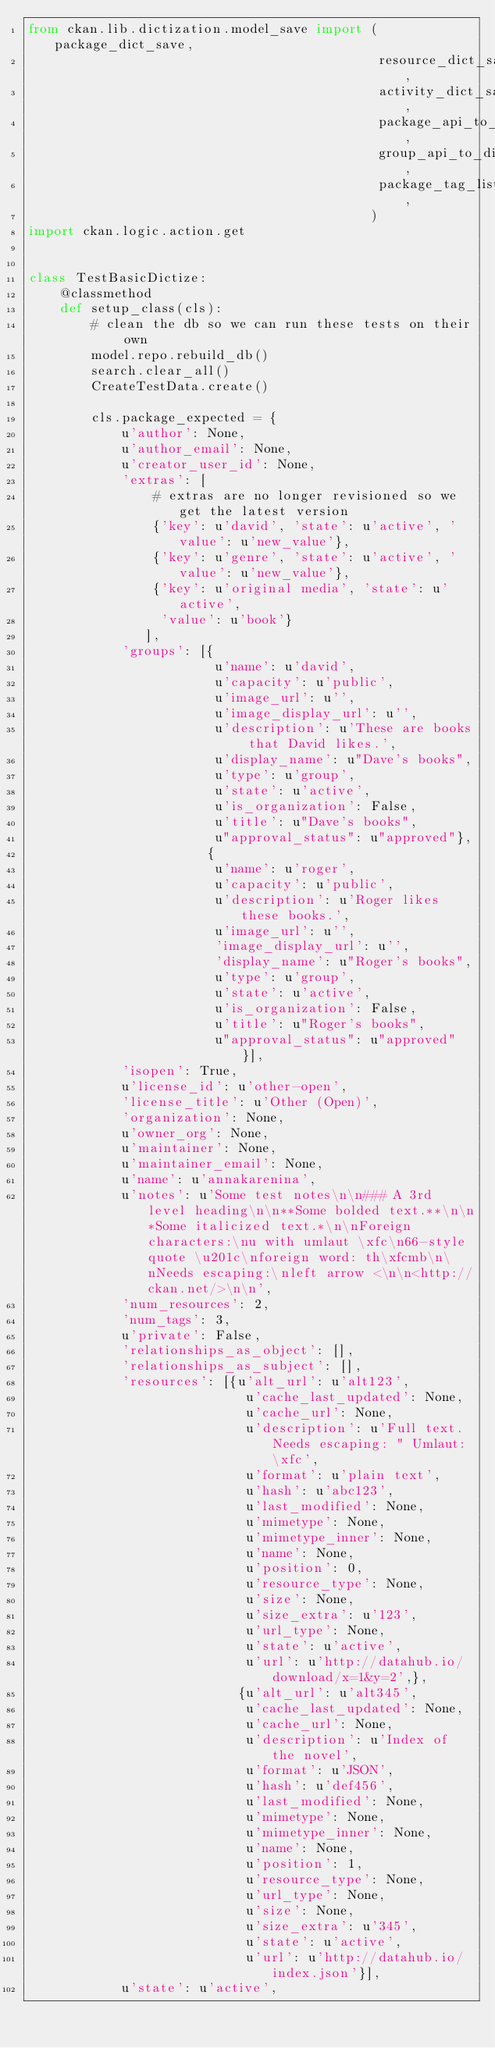<code> <loc_0><loc_0><loc_500><loc_500><_Python_>from ckan.lib.dictization.model_save import (package_dict_save,
                                             resource_dict_save,
                                             activity_dict_save,
                                             package_api_to_dict,
                                             group_api_to_dict,
                                             package_tag_list_save,
                                            )
import ckan.logic.action.get


class TestBasicDictize:
    @classmethod
    def setup_class(cls):
        # clean the db so we can run these tests on their own
        model.repo.rebuild_db()
        search.clear_all()
        CreateTestData.create()

        cls.package_expected = {
            u'author': None,
            u'author_email': None,
            u'creator_user_id': None,
            'extras': [
                # extras are no longer revisioned so we get the latest version
                {'key': u'david', 'state': u'active', 'value': u'new_value'},
                {'key': u'genre', 'state': u'active', 'value': u'new_value'},
                {'key': u'original media', 'state': u'active',
                 'value': u'book'}
               ],
            'groups': [{
                        u'name': u'david',
                        u'capacity': u'public',
                        u'image_url': u'',
                        u'image_display_url': u'',
                        u'description': u'These are books that David likes.',
                        u'display_name': u"Dave's books",
                        u'type': u'group',
                        u'state': u'active',
                        u'is_organization': False,
                        u'title': u"Dave's books",
                        u"approval_status": u"approved"},
                       {
                        u'name': u'roger',
                        u'capacity': u'public',
                        u'description': u'Roger likes these books.',
                        u'image_url': u'',
                        'image_display_url': u'',
                        'display_name': u"Roger's books",
                        u'type': u'group',
                        u'state': u'active',
                        u'is_organization': False,
                        u'title': u"Roger's books",
                        u"approval_status": u"approved"}],
            'isopen': True,
            u'license_id': u'other-open',
            'license_title': u'Other (Open)',
            'organization': None,
            u'owner_org': None,
            u'maintainer': None,
            u'maintainer_email': None,
            u'name': u'annakarenina',
            u'notes': u'Some test notes\n\n### A 3rd level heading\n\n**Some bolded text.**\n\n*Some italicized text.*\n\nForeign characters:\nu with umlaut \xfc\n66-style quote \u201c\nforeign word: th\xfcmb\n\nNeeds escaping:\nleft arrow <\n\n<http://ckan.net/>\n\n',
            'num_resources': 2,
            'num_tags': 3,
            u'private': False,
            'relationships_as_object': [],
            'relationships_as_subject': [],
            'resources': [{u'alt_url': u'alt123',
                            u'cache_last_updated': None,
                            u'cache_url': None,
                            u'description': u'Full text. Needs escaping: " Umlaut: \xfc',
                            u'format': u'plain text',
                            u'hash': u'abc123',
                            u'last_modified': None,
                            u'mimetype': None,
                            u'mimetype_inner': None,
                            u'name': None,
                            u'position': 0,
                            u'resource_type': None,
                            u'size': None,
                            u'size_extra': u'123',
                            u'url_type': None,
                            u'state': u'active',
                            u'url': u'http://datahub.io/download/x=1&y=2',},
                           {u'alt_url': u'alt345',
                            u'cache_last_updated': None,
                            u'cache_url': None,
                            u'description': u'Index of the novel',
                            u'format': u'JSON',
                            u'hash': u'def456',
                            u'last_modified': None,
                            u'mimetype': None,
                            u'mimetype_inner': None,
                            u'name': None,
                            u'position': 1,
                            u'resource_type': None,
                            u'url_type': None,
                            u'size': None,
                            u'size_extra': u'345',
                            u'state': u'active',
                            u'url': u'http://datahub.io/index.json'}],
            u'state': u'active',</code> 